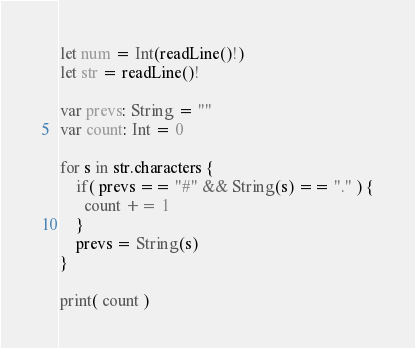Convert code to text. <code><loc_0><loc_0><loc_500><loc_500><_Swift_>let num = Int(readLine()!)
let str = readLine()!

var prevs: String = ""
var count: Int = 0

for s in str.characters {
    if( prevs == "#" && String(s) == "." ) {
      count += 1
    }
  	prevs = String(s)
}

print( count )</code> 